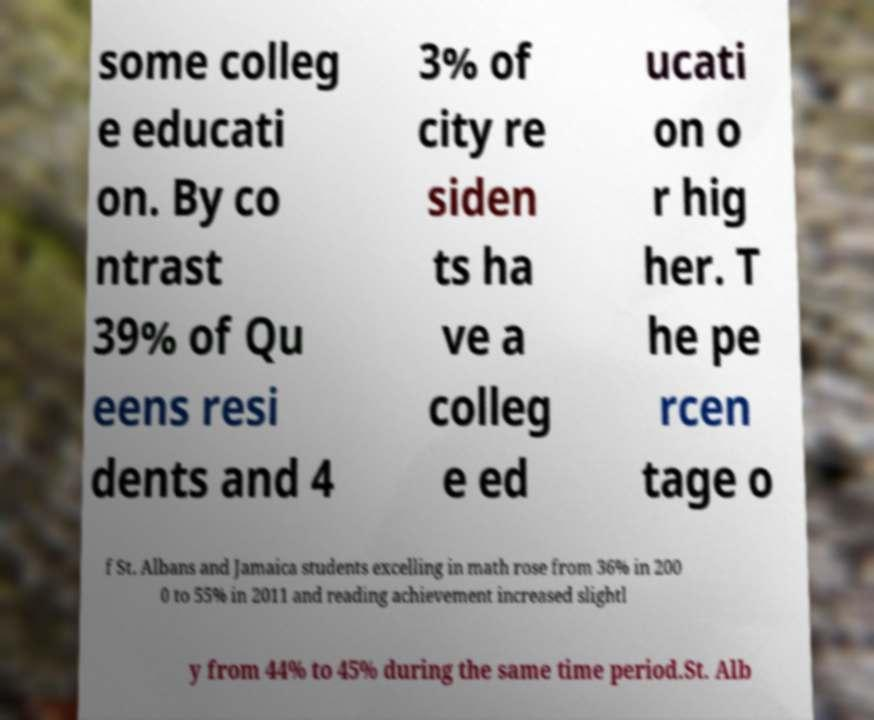Can you read and provide the text displayed in the image?This photo seems to have some interesting text. Can you extract and type it out for me? some colleg e educati on. By co ntrast 39% of Qu eens resi dents and 4 3% of city re siden ts ha ve a colleg e ed ucati on o r hig her. T he pe rcen tage o f St. Albans and Jamaica students excelling in math rose from 36% in 200 0 to 55% in 2011 and reading achievement increased slightl y from 44% to 45% during the same time period.St. Alb 